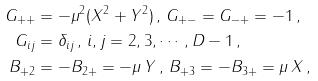<formula> <loc_0><loc_0><loc_500><loc_500>G _ { + + } & = - \mu ^ { 2 } ( X ^ { 2 } + Y ^ { 2 } ) \, , \, G _ { + - } = G _ { - + } = - 1 \, , \\ G _ { i j } & = \delta _ { i j } \, , \, i , j = 2 , 3 , \cdots , D - 1 \, , \\ B _ { + 2 } & = - B _ { 2 + } = - \mu \, Y \, , \, B _ { + 3 } = - B _ { 3 + } = \mu \, X \, ,</formula> 